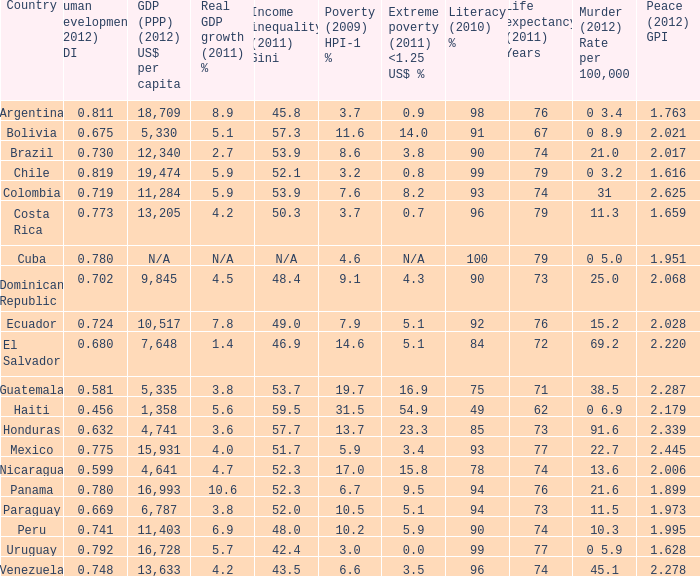Parse the table in full. {'header': ['Country', 'Human development (2012) HDI', 'GDP (PPP) (2012) US$ per capita', 'Real GDP growth (2011) %', 'Income inequality (2011) Gini', 'Poverty (2009) HPI-1 %', 'Extreme poverty (2011) <1.25 US$ %', 'Literacy (2010) %', 'Life expectancy (2011) Years', 'Murder (2012) Rate per 100,000', 'Peace (2012) GPI'], 'rows': [['Argentina', '0.811', '18,709', '8.9', '45.8', '3.7', '0.9', '98', '76', '0 3.4', '1.763'], ['Bolivia', '0.675', '5,330', '5.1', '57.3', '11.6', '14.0', '91', '67', '0 8.9', '2.021'], ['Brazil', '0.730', '12,340', '2.7', '53.9', '8.6', '3.8', '90', '74', '21.0', '2.017'], ['Chile', '0.819', '19,474', '5.9', '52.1', '3.2', '0.8', '99', '79', '0 3.2', '1.616'], ['Colombia', '0.719', '11,284', '5.9', '53.9', '7.6', '8.2', '93', '74', '31', '2.625'], ['Costa Rica', '0.773', '13,205', '4.2', '50.3', '3.7', '0.7', '96', '79', '11.3', '1.659'], ['Cuba', '0.780', 'N/A', 'N/A', 'N/A', '4.6', 'N/A', '100', '79', '0 5.0', '1.951'], ['Dominican Republic', '0.702', '9,845', '4.5', '48.4', '9.1', '4.3', '90', '73', '25.0', '2.068'], ['Ecuador', '0.724', '10,517', '7.8', '49.0', '7.9', '5.1', '92', '76', '15.2', '2.028'], ['El Salvador', '0.680', '7,648', '1.4', '46.9', '14.6', '5.1', '84', '72', '69.2', '2.220'], ['Guatemala', '0.581', '5,335', '3.8', '53.7', '19.7', '16.9', '75', '71', '38.5', '2.287'], ['Haiti', '0.456', '1,358', '5.6', '59.5', '31.5', '54.9', '49', '62', '0 6.9', '2.179'], ['Honduras', '0.632', '4,741', '3.6', '57.7', '13.7', '23.3', '85', '73', '91.6', '2.339'], ['Mexico', '0.775', '15,931', '4.0', '51.7', '5.9', '3.4', '93', '77', '22.7', '2.445'], ['Nicaragua', '0.599', '4,641', '4.7', '52.3', '17.0', '15.8', '78', '74', '13.6', '2.006'], ['Panama', '0.780', '16,993', '10.6', '52.3', '6.7', '9.5', '94', '76', '21.6', '1.899'], ['Paraguay', '0.669', '6,787', '3.8', '52.0', '10.5', '5.1', '94', '73', '11.5', '1.973'], ['Peru', '0.741', '11,403', '6.9', '48.0', '10.2', '5.9', '90', '74', '10.3', '1.995'], ['Uruguay', '0.792', '16,728', '5.7', '42.4', '3.0', '0.0', '99', '77', '0 5.9', '1.628'], ['Venezuela', '0.748', '13,633', '4.2', '43.5', '6.6', '3.5', '96', '74', '45.1', '2.278']]} 616 as the tranquility (2012) gpi? 0 3.2. 